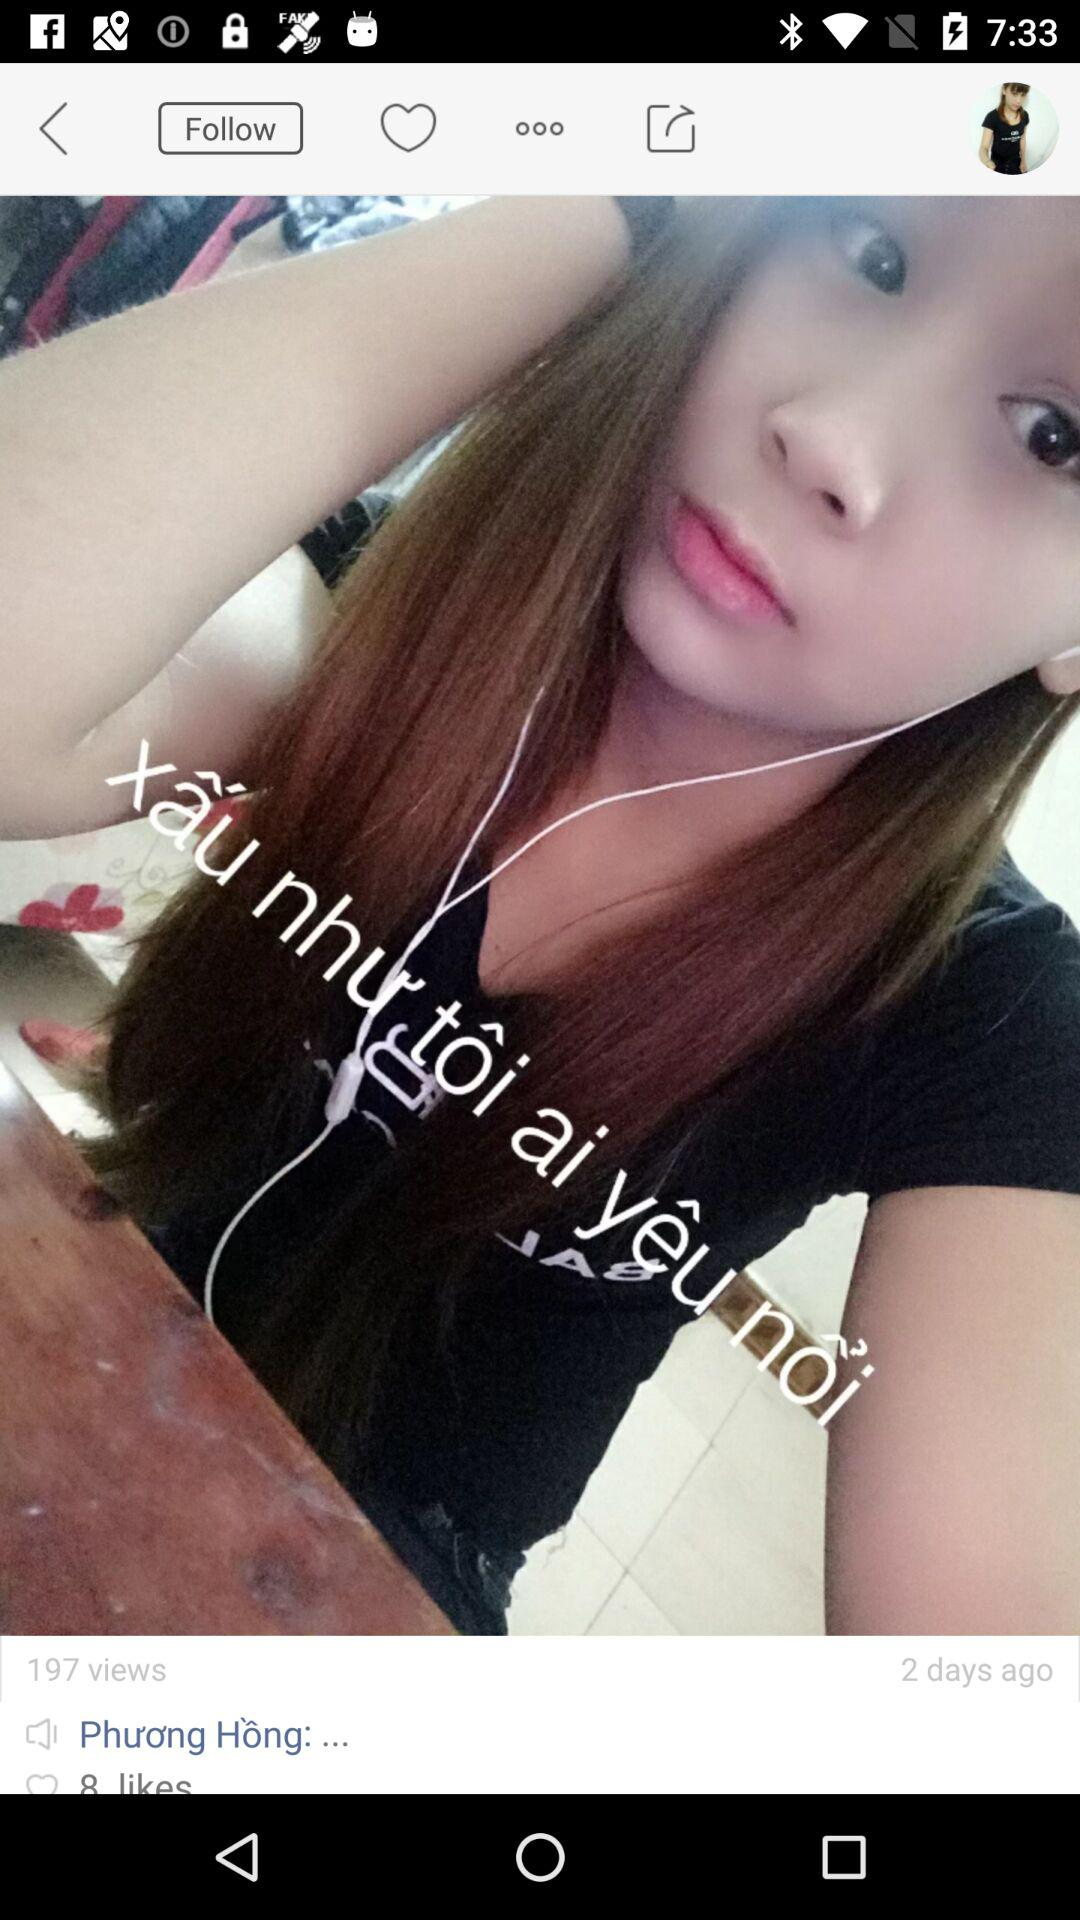When was the picture posted? The picture was posted 2 days ago. 